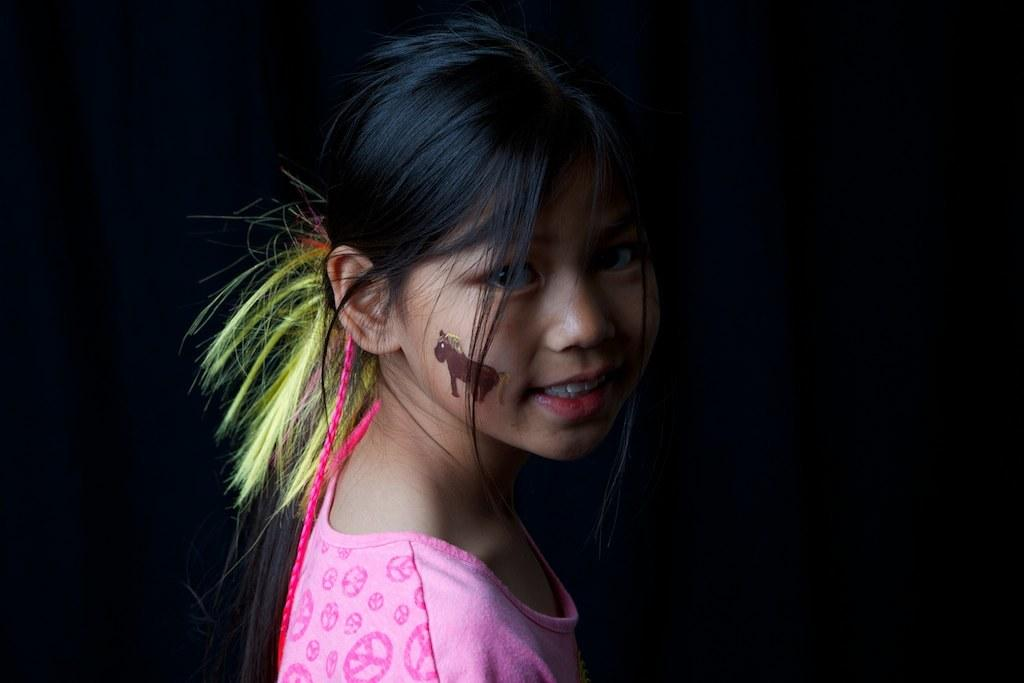Who is the main subject in the image? There is a girl in the image. What is the girl wearing? The girl is wearing a pink t-shirt. What is the girl's facial expression in the image? The girl is smiling. What is the girl doing in the image? The girl is giving a pose for the picture. What color is the background of the image? The background of the image is black. What is the girl feeling in the image? The girl is smiling, which suggests she is feeling happy or content. However, we cannot determine her exact emotions from the image alone. How many babies are present in the image? There are no babies present in the image; it features a girl posing for a picture. 